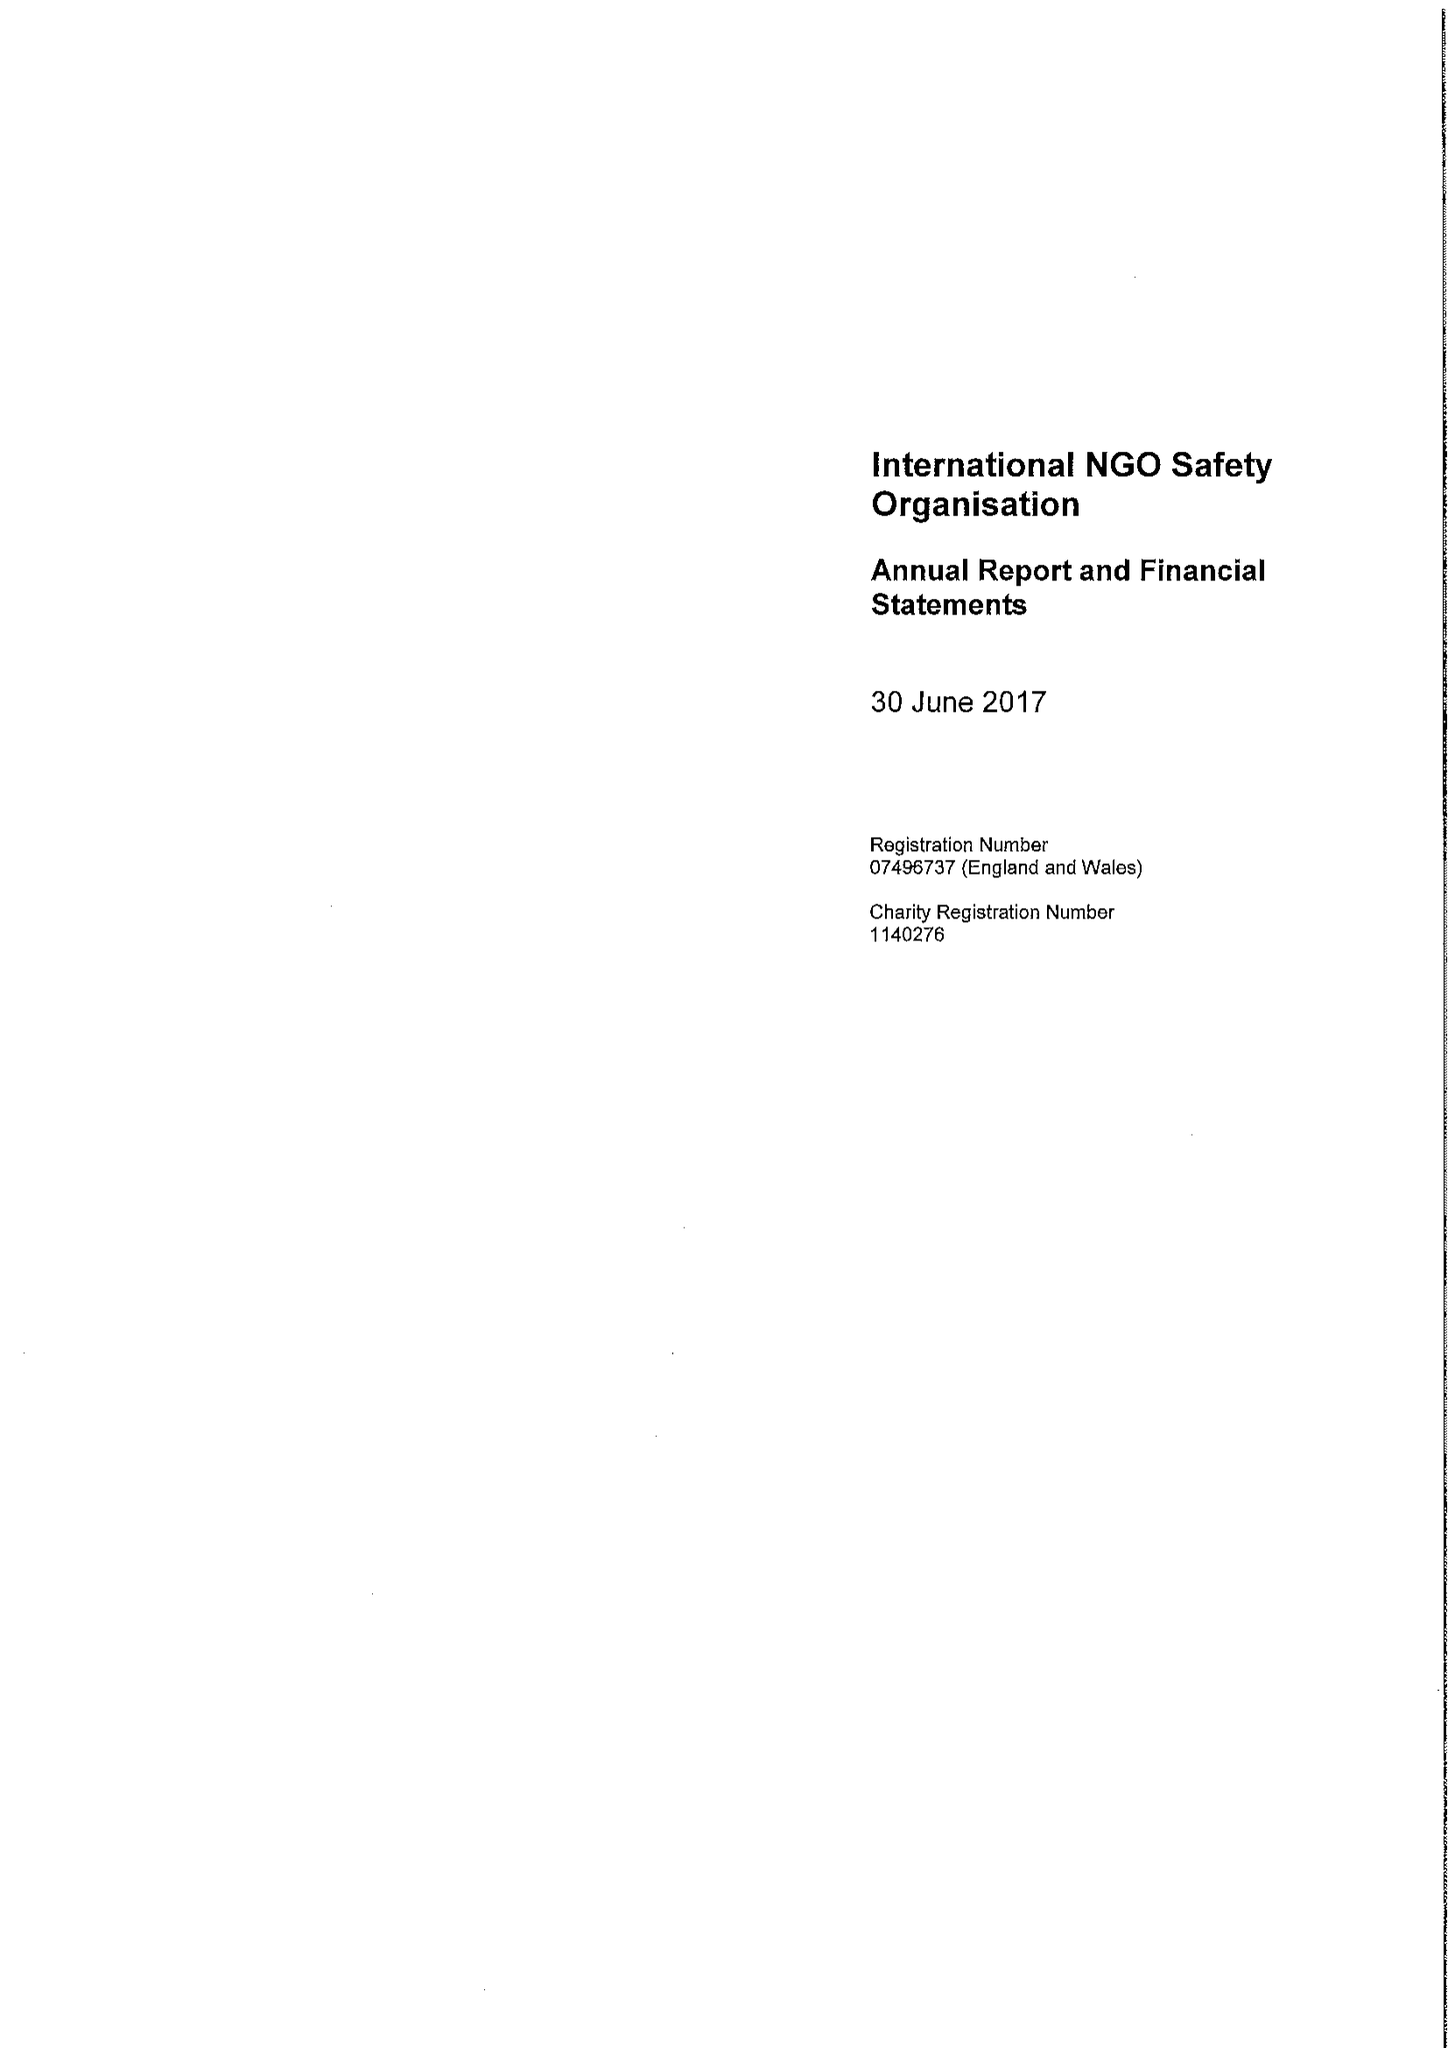What is the value for the charity_name?
Answer the question using a single word or phrase. International Ngo Safety Organisation 